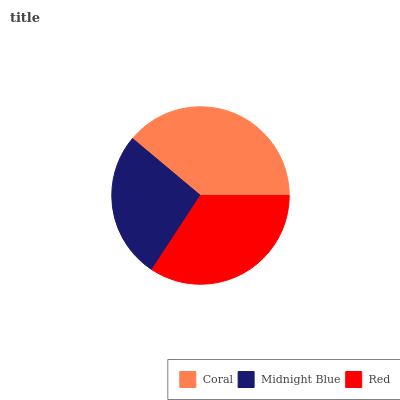Is Midnight Blue the minimum?
Answer yes or no. Yes. Is Coral the maximum?
Answer yes or no. Yes. Is Red the minimum?
Answer yes or no. No. Is Red the maximum?
Answer yes or no. No. Is Red greater than Midnight Blue?
Answer yes or no. Yes. Is Midnight Blue less than Red?
Answer yes or no. Yes. Is Midnight Blue greater than Red?
Answer yes or no. No. Is Red less than Midnight Blue?
Answer yes or no. No. Is Red the high median?
Answer yes or no. Yes. Is Red the low median?
Answer yes or no. Yes. Is Coral the high median?
Answer yes or no. No. Is Midnight Blue the low median?
Answer yes or no. No. 